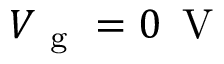<formula> <loc_0><loc_0><loc_500><loc_500>V _ { g } = 0 \, V</formula> 